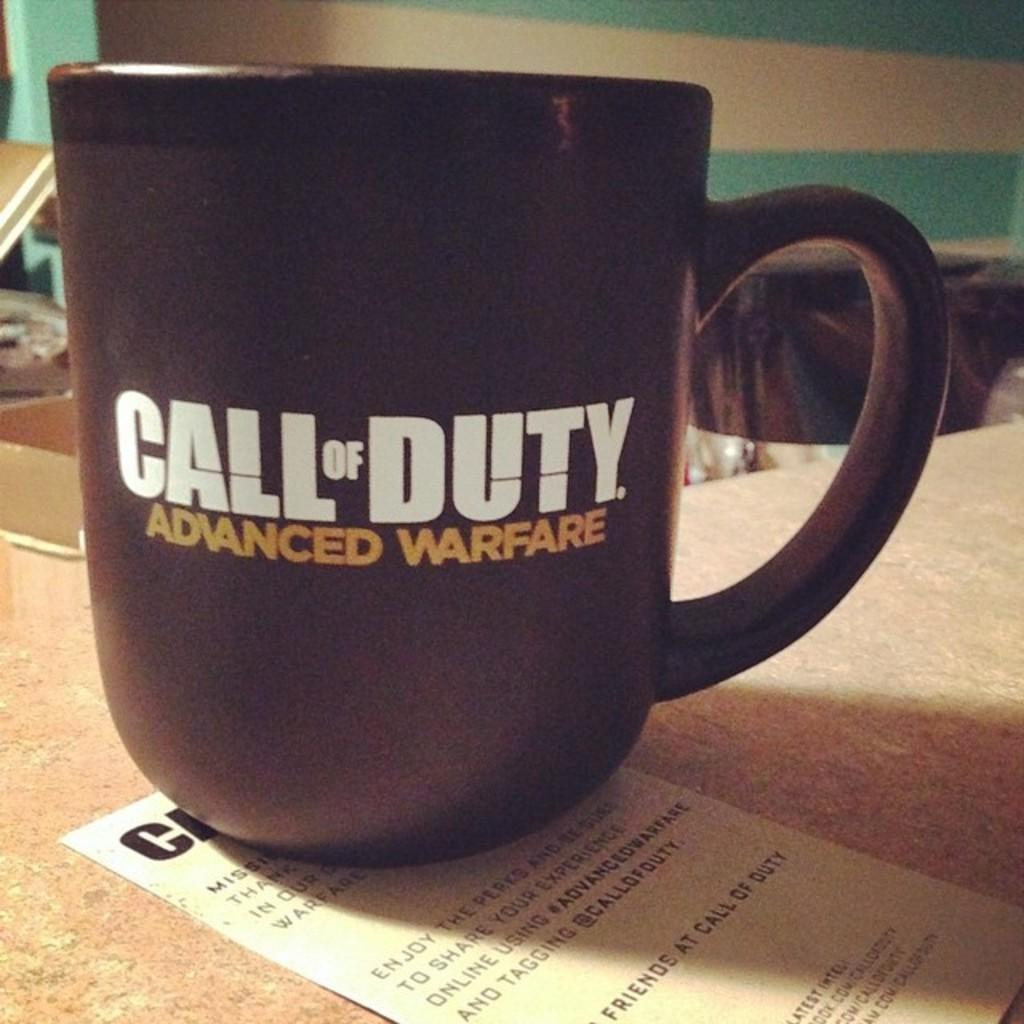<image>
Provide a brief description of the given image. A coffee mug that displays Call of Duty Advanced Warfare 